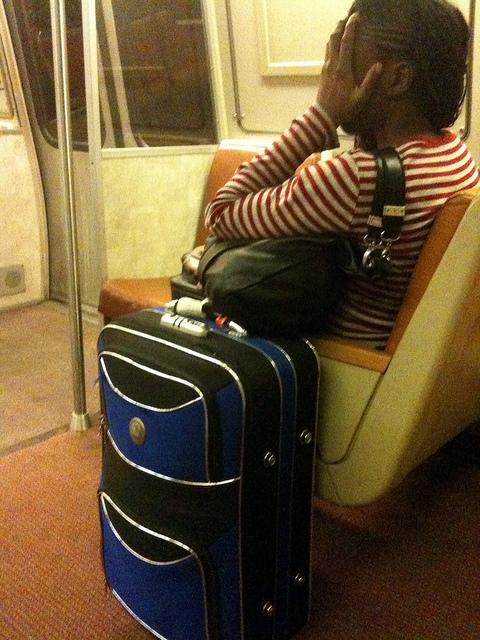What is the color of the suitcase?
Answer briefly. Blue and black. What color is the suitcase?
Answer briefly. Blue and black. Is this person on a train?
Be succinct. Yes. 